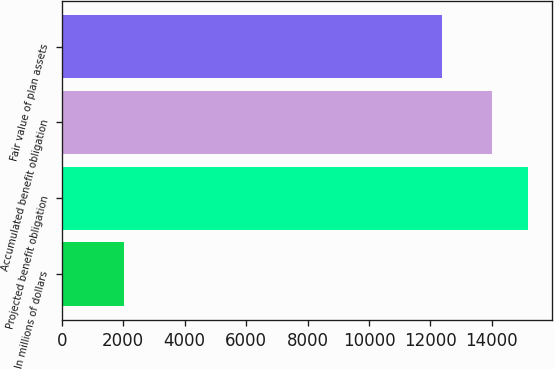<chart> <loc_0><loc_0><loc_500><loc_500><bar_chart><fcel>In millions of dollars<fcel>Projected benefit obligation<fcel>Accumulated benefit obligation<fcel>Fair value of plan assets<nl><fcel>2016<fcel>15192.4<fcel>13994<fcel>12363<nl></chart> 